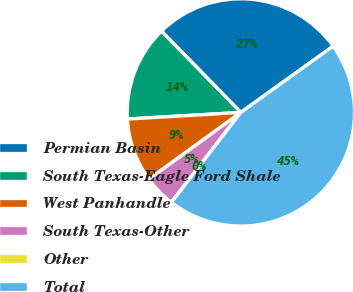Convert chart to OTSL. <chart><loc_0><loc_0><loc_500><loc_500><pie_chart><fcel>Permian Basin<fcel>South Texas-Eagle Ford Shale<fcel>West Panhandle<fcel>South Texas-Other<fcel>Other<fcel>Total<nl><fcel>27.4%<fcel>13.62%<fcel>9.07%<fcel>4.54%<fcel>0.0%<fcel>45.37%<nl></chart> 